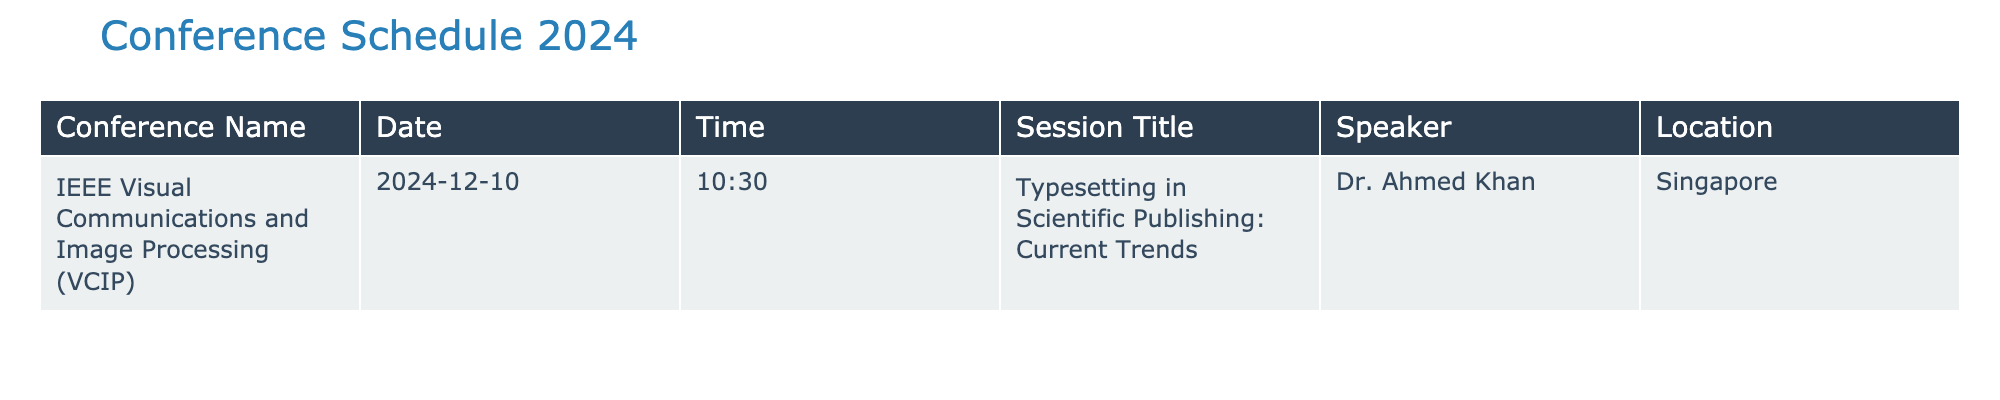What is the title of the session on December 10, 2024? The table lists the session title for December 10, 2024, under the "Session Title" column. The title provided is "Typesetting in Scientific Publishing: Current Trends."
Answer: Typesetting in Scientific Publishing: Current Trends Who is the speaker for the session on typesetting? The speaker's name is found in the "Speaker" column adjacent to the session title. It shows "Dr. Ahmed Khan" for the specified date.
Answer: Dr. Ahmed Khan Is the conference taking place in Singapore? By looking at the "Location" column for the conference entry on December 10, 2024, it indicates "Singapore" as the location, confirming the fact.
Answer: Yes What time does the session on typesetting start? The "Time" column for the related entry specifies that the session starts at "10:30" on December 10, 2024.
Answer: 10:30 How many unique speakers are listed for the conference? There is only one entry in the table for the specified date, hence only one unique speaker, which is "Dr. Ahmed Khan." This is confirmed by looking through the "Speaker" column.
Answer: 1 Could you confirm if there are any sessions scheduled for December 11, 2024? The table only lists a session for December 10, 2024, and does not mention any session for December 11, 2024, thus the answer to the query is clear.
Answer: No What is the name of the conference scheduled for December 10, 2024? The table provides a column named "Conference Name," where the corresponding entry for December 10, 2024, is "IEEE Visual Communications and Image Processing (VCIP)."
Answer: IEEE Visual Communications and Image Processing (VCIP) If we consider the session time, what is the duration in hours until noon on the same day? The time of the session is "10:30," which is 1 hour and 30 minutes away from noon (12:00). Thus, converting that to hours, it is 1.5 hours.
Answer: 1.5 What is the main theme of the conference as indicated by the session title? The session title "Typesetting in Scientific Publishing: Current Trends" suggests that the main theme revolves around the current practices and advancements in typesetting concerning scientific publishing.
Answer: Typesetting in Scientific Publishing 